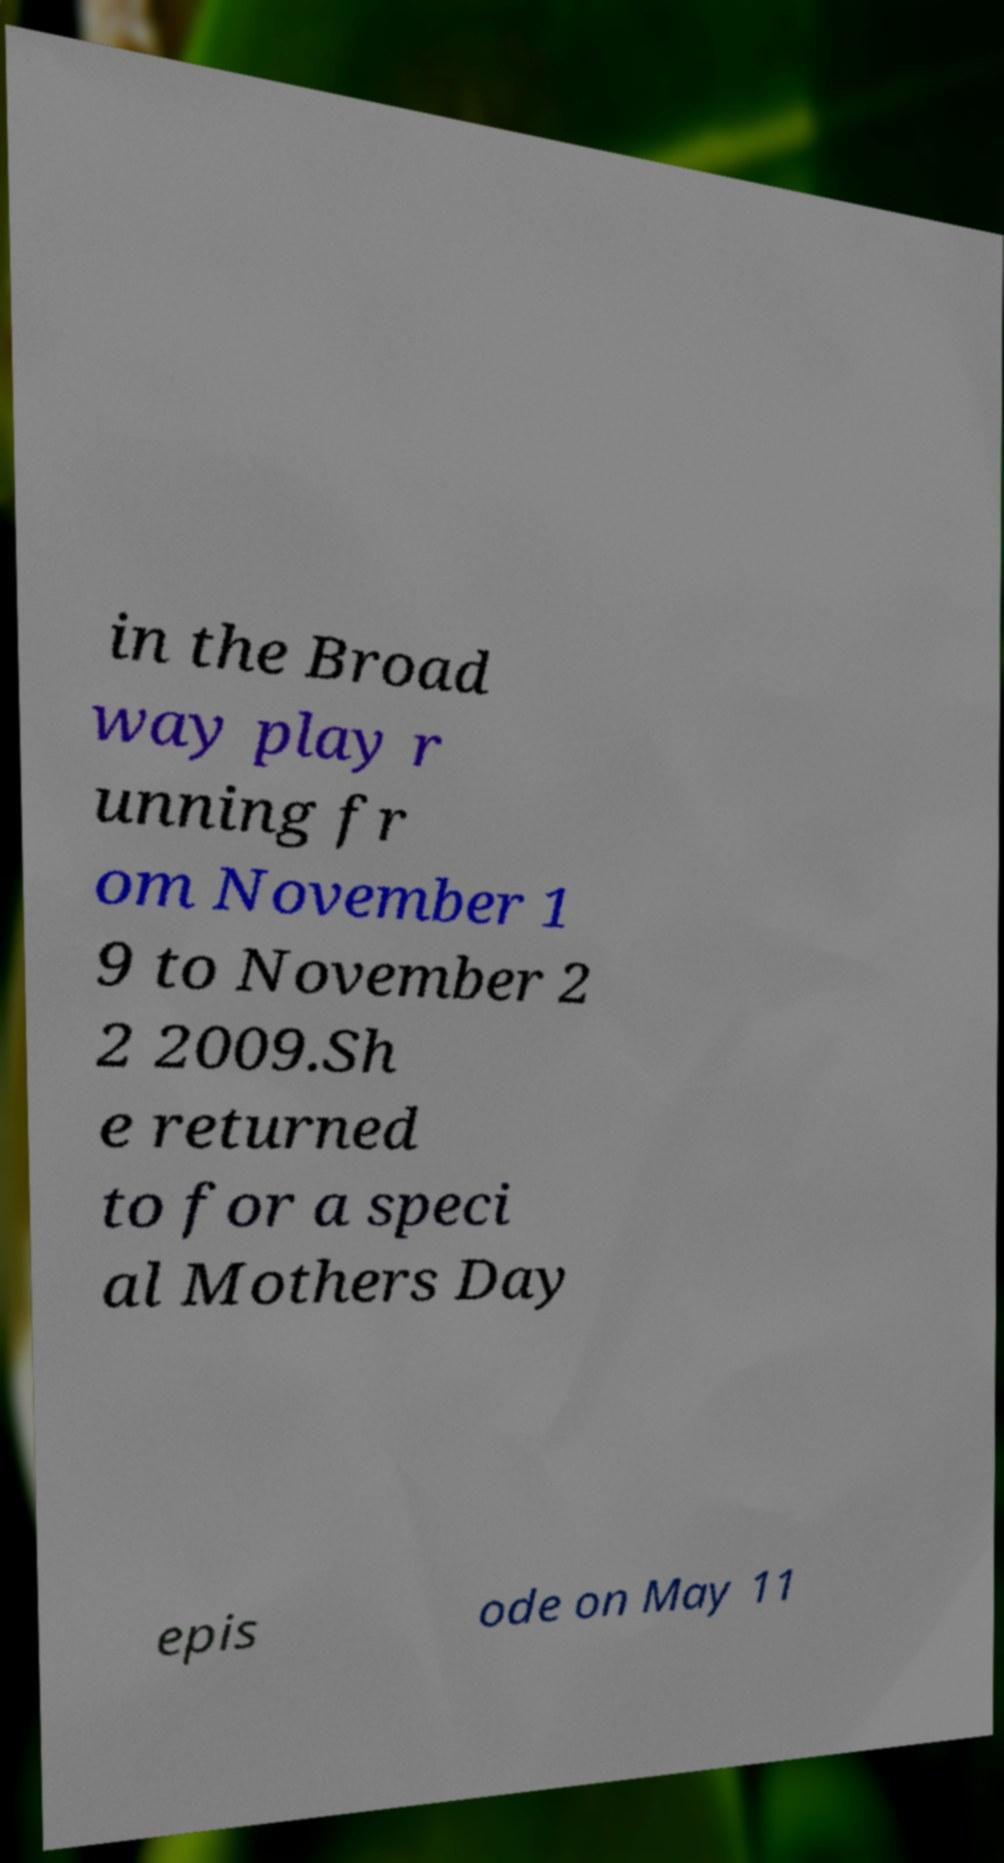Please read and relay the text visible in this image. What does it say? in the Broad way play r unning fr om November 1 9 to November 2 2 2009.Sh e returned to for a speci al Mothers Day epis ode on May 11 